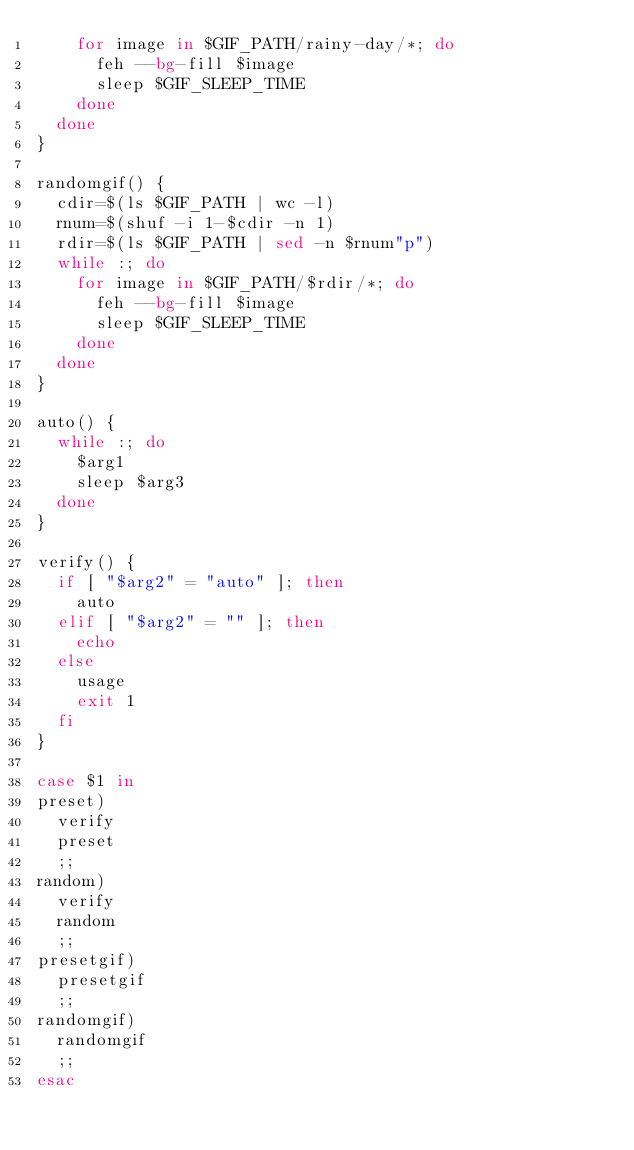Convert code to text. <code><loc_0><loc_0><loc_500><loc_500><_Bash_>    for image in $GIF_PATH/rainy-day/*; do
      feh --bg-fill $image
      sleep $GIF_SLEEP_TIME
    done
  done
}

randomgif() {
  cdir=$(ls $GIF_PATH | wc -l)
  rnum=$(shuf -i 1-$cdir -n 1)
  rdir=$(ls $GIF_PATH | sed -n $rnum"p")
  while :; do
    for image in $GIF_PATH/$rdir/*; do
      feh --bg-fill $image
      sleep $GIF_SLEEP_TIME
    done
  done
}

auto() {
  while :; do
    $arg1
    sleep $arg3
  done
}

verify() {
  if [ "$arg2" = "auto" ]; then
    auto
  elif [ "$arg2" = "" ]; then
    echo
  else
    usage
    exit 1
  fi
}

case $1 in
preset)
  verify
  preset
  ;;
random)
  verify
  random
  ;;
presetgif)
  presetgif
  ;;
randomgif)
  randomgif
  ;;
esac
</code> 